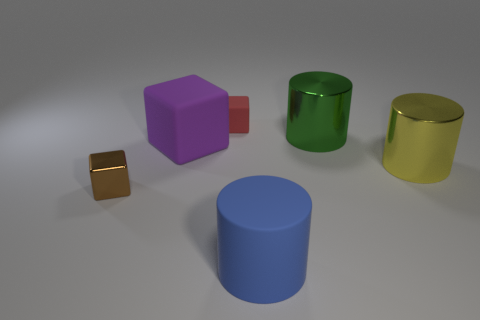Subtract 1 cubes. How many cubes are left? 2 Subtract all metal cylinders. How many cylinders are left? 1 Add 1 large blue things. How many objects exist? 7 Subtract 0 gray balls. How many objects are left? 6 Subtract all big blue matte cylinders. Subtract all red things. How many objects are left? 4 Add 1 large blue cylinders. How many large blue cylinders are left? 2 Add 1 tiny red shiny blocks. How many tiny red shiny blocks exist? 1 